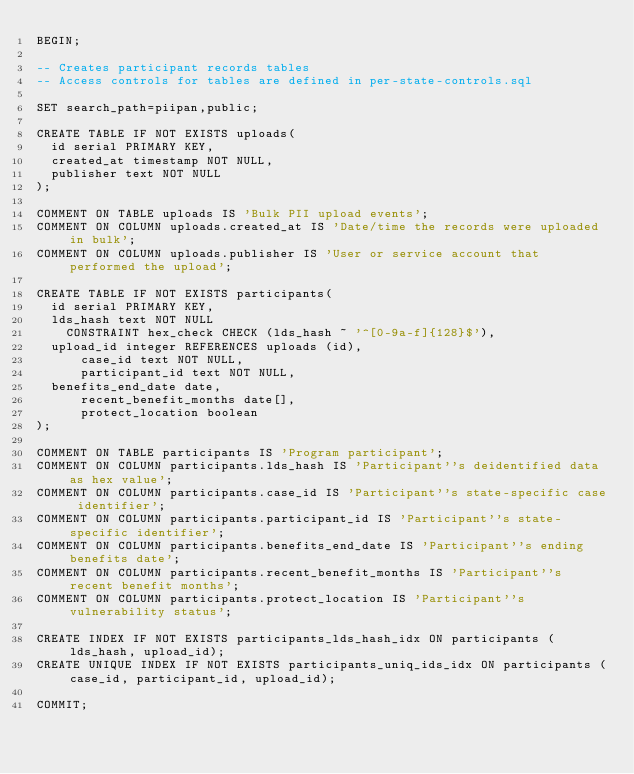Convert code to text. <code><loc_0><loc_0><loc_500><loc_500><_SQL_>BEGIN;

-- Creates participant records tables
-- Access controls for tables are defined in per-state-controls.sql

SET search_path=piipan,public;

CREATE TABLE IF NOT EXISTS uploads(
	id serial PRIMARY KEY,
	created_at timestamp NOT NULL,
	publisher text NOT NULL
);

COMMENT ON TABLE uploads IS 'Bulk PII upload events';
COMMENT ON COLUMN uploads.created_at IS 'Date/time the records were uploaded in bulk';
COMMENT ON COLUMN uploads.publisher IS 'User or service account that performed the upload';

CREATE TABLE IF NOT EXISTS participants(
	id serial PRIMARY KEY,
	lds_hash text NOT NULL
		CONSTRAINT hex_check CHECK (lds_hash ~ '^[0-9a-f]{128}$'),
	upload_id integer REFERENCES uploads (id),
    	case_id text NOT NULL,
    	participant_id text NOT NULL,
	benefits_end_date date,
    	recent_benefit_months date[],
    	protect_location boolean
);

COMMENT ON TABLE participants IS 'Program participant';
COMMENT ON COLUMN participants.lds_hash IS 'Participant''s deidentified data as hex value';
COMMENT ON COLUMN participants.case_id IS 'Participant''s state-specific case identifier';
COMMENT ON COLUMN participants.participant_id IS 'Participant''s state-specific identifier';
COMMENT ON COLUMN participants.benefits_end_date IS 'Participant''s ending benefits date';
COMMENT ON COLUMN participants.recent_benefit_months IS 'Participant''s recent benefit months';
COMMENT ON COLUMN participants.protect_location IS 'Participant''s vulnerability status';

CREATE INDEX IF NOT EXISTS participants_lds_hash_idx ON participants (lds_hash, upload_id);
CREATE UNIQUE INDEX IF NOT EXISTS participants_uniq_ids_idx ON participants (case_id, participant_id, upload_id);

COMMIT;
</code> 